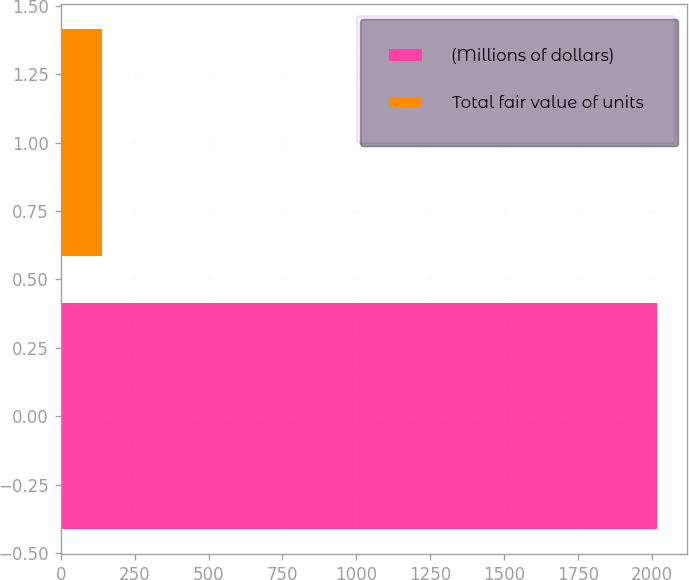Convert chart. <chart><loc_0><loc_0><loc_500><loc_500><bar_chart><fcel>(Millions of dollars)<fcel>Total fair value of units<nl><fcel>2017<fcel>139<nl></chart> 